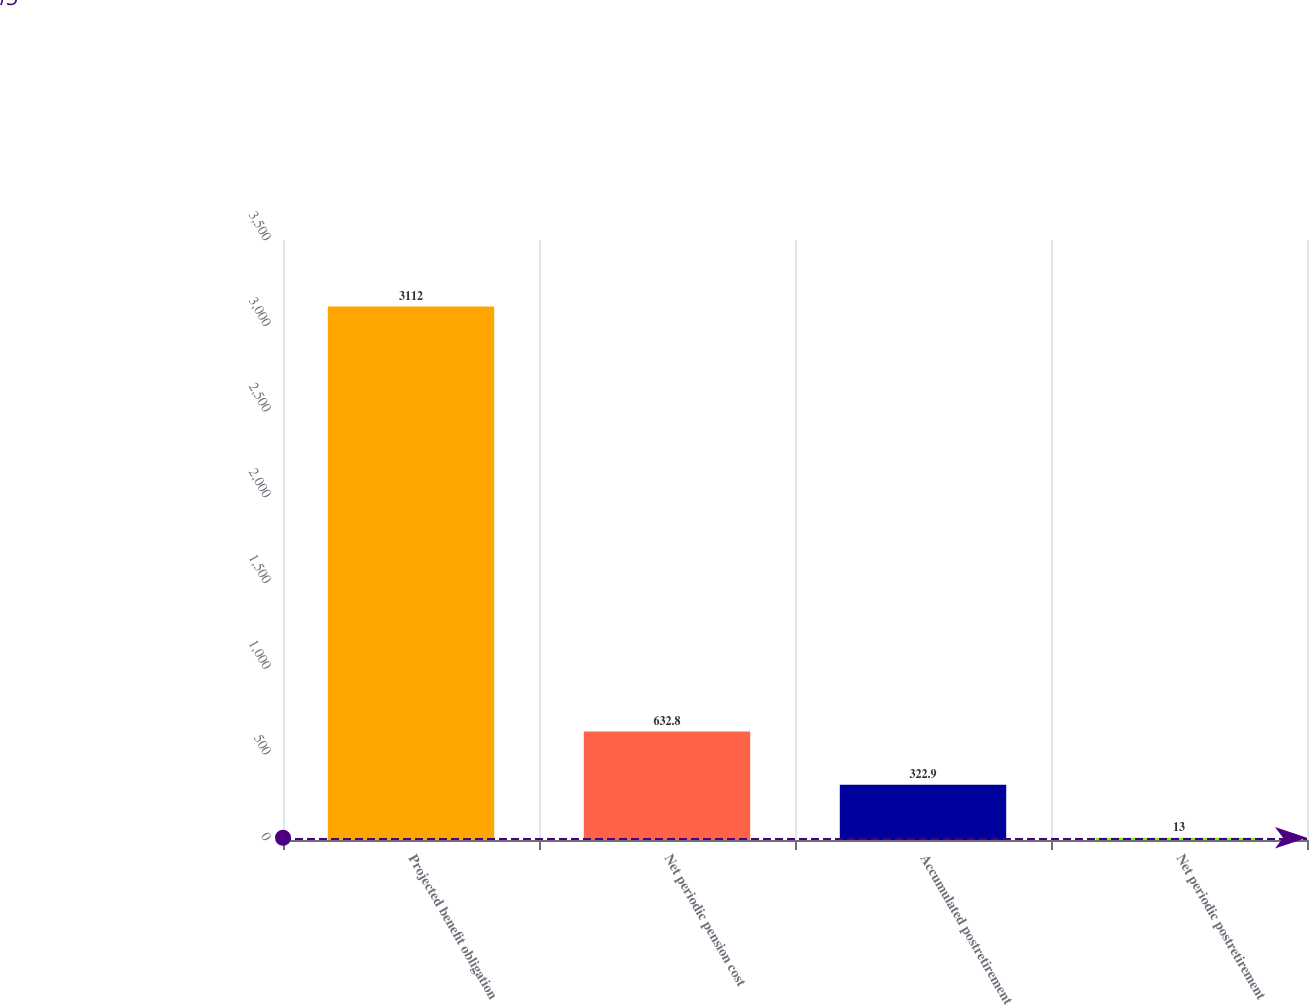Convert chart. <chart><loc_0><loc_0><loc_500><loc_500><bar_chart><fcel>Projected benefit obligation<fcel>Net periodic pension cost<fcel>Accumulated postretirement<fcel>Net periodic postretirement<nl><fcel>3112<fcel>632.8<fcel>322.9<fcel>13<nl></chart> 